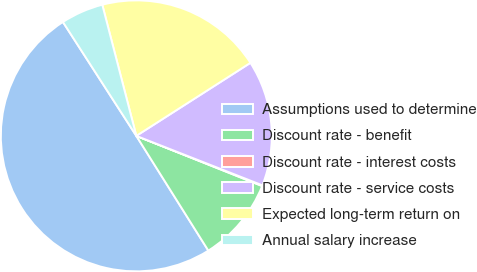Convert chart to OTSL. <chart><loc_0><loc_0><loc_500><loc_500><pie_chart><fcel>Assumptions used to determine<fcel>Discount rate - benefit<fcel>Discount rate - interest costs<fcel>Discount rate - service costs<fcel>Expected long-term return on<fcel>Annual salary increase<nl><fcel>49.81%<fcel>10.04%<fcel>0.09%<fcel>15.01%<fcel>19.98%<fcel>5.07%<nl></chart> 